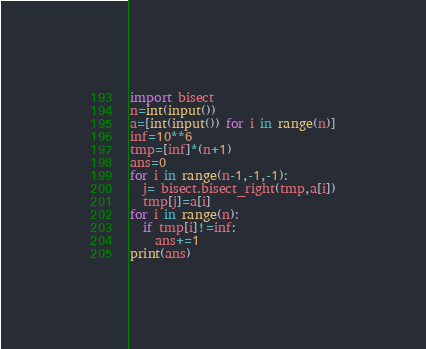Convert code to text. <code><loc_0><loc_0><loc_500><loc_500><_Python_>import bisect
n=int(input())
a=[int(input()) for i in range(n)]
inf=10**6
tmp=[inf]*(n+1)
ans=0
for i in range(n-1,-1,-1):
  j= bisect.bisect_right(tmp,a[i])
  tmp[j]=a[i]
for i in range(n):
  if tmp[i]!=inf:
    ans+=1
print(ans)

</code> 